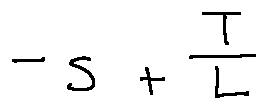<formula> <loc_0><loc_0><loc_500><loc_500>- s + \frac { T } { L }</formula> 